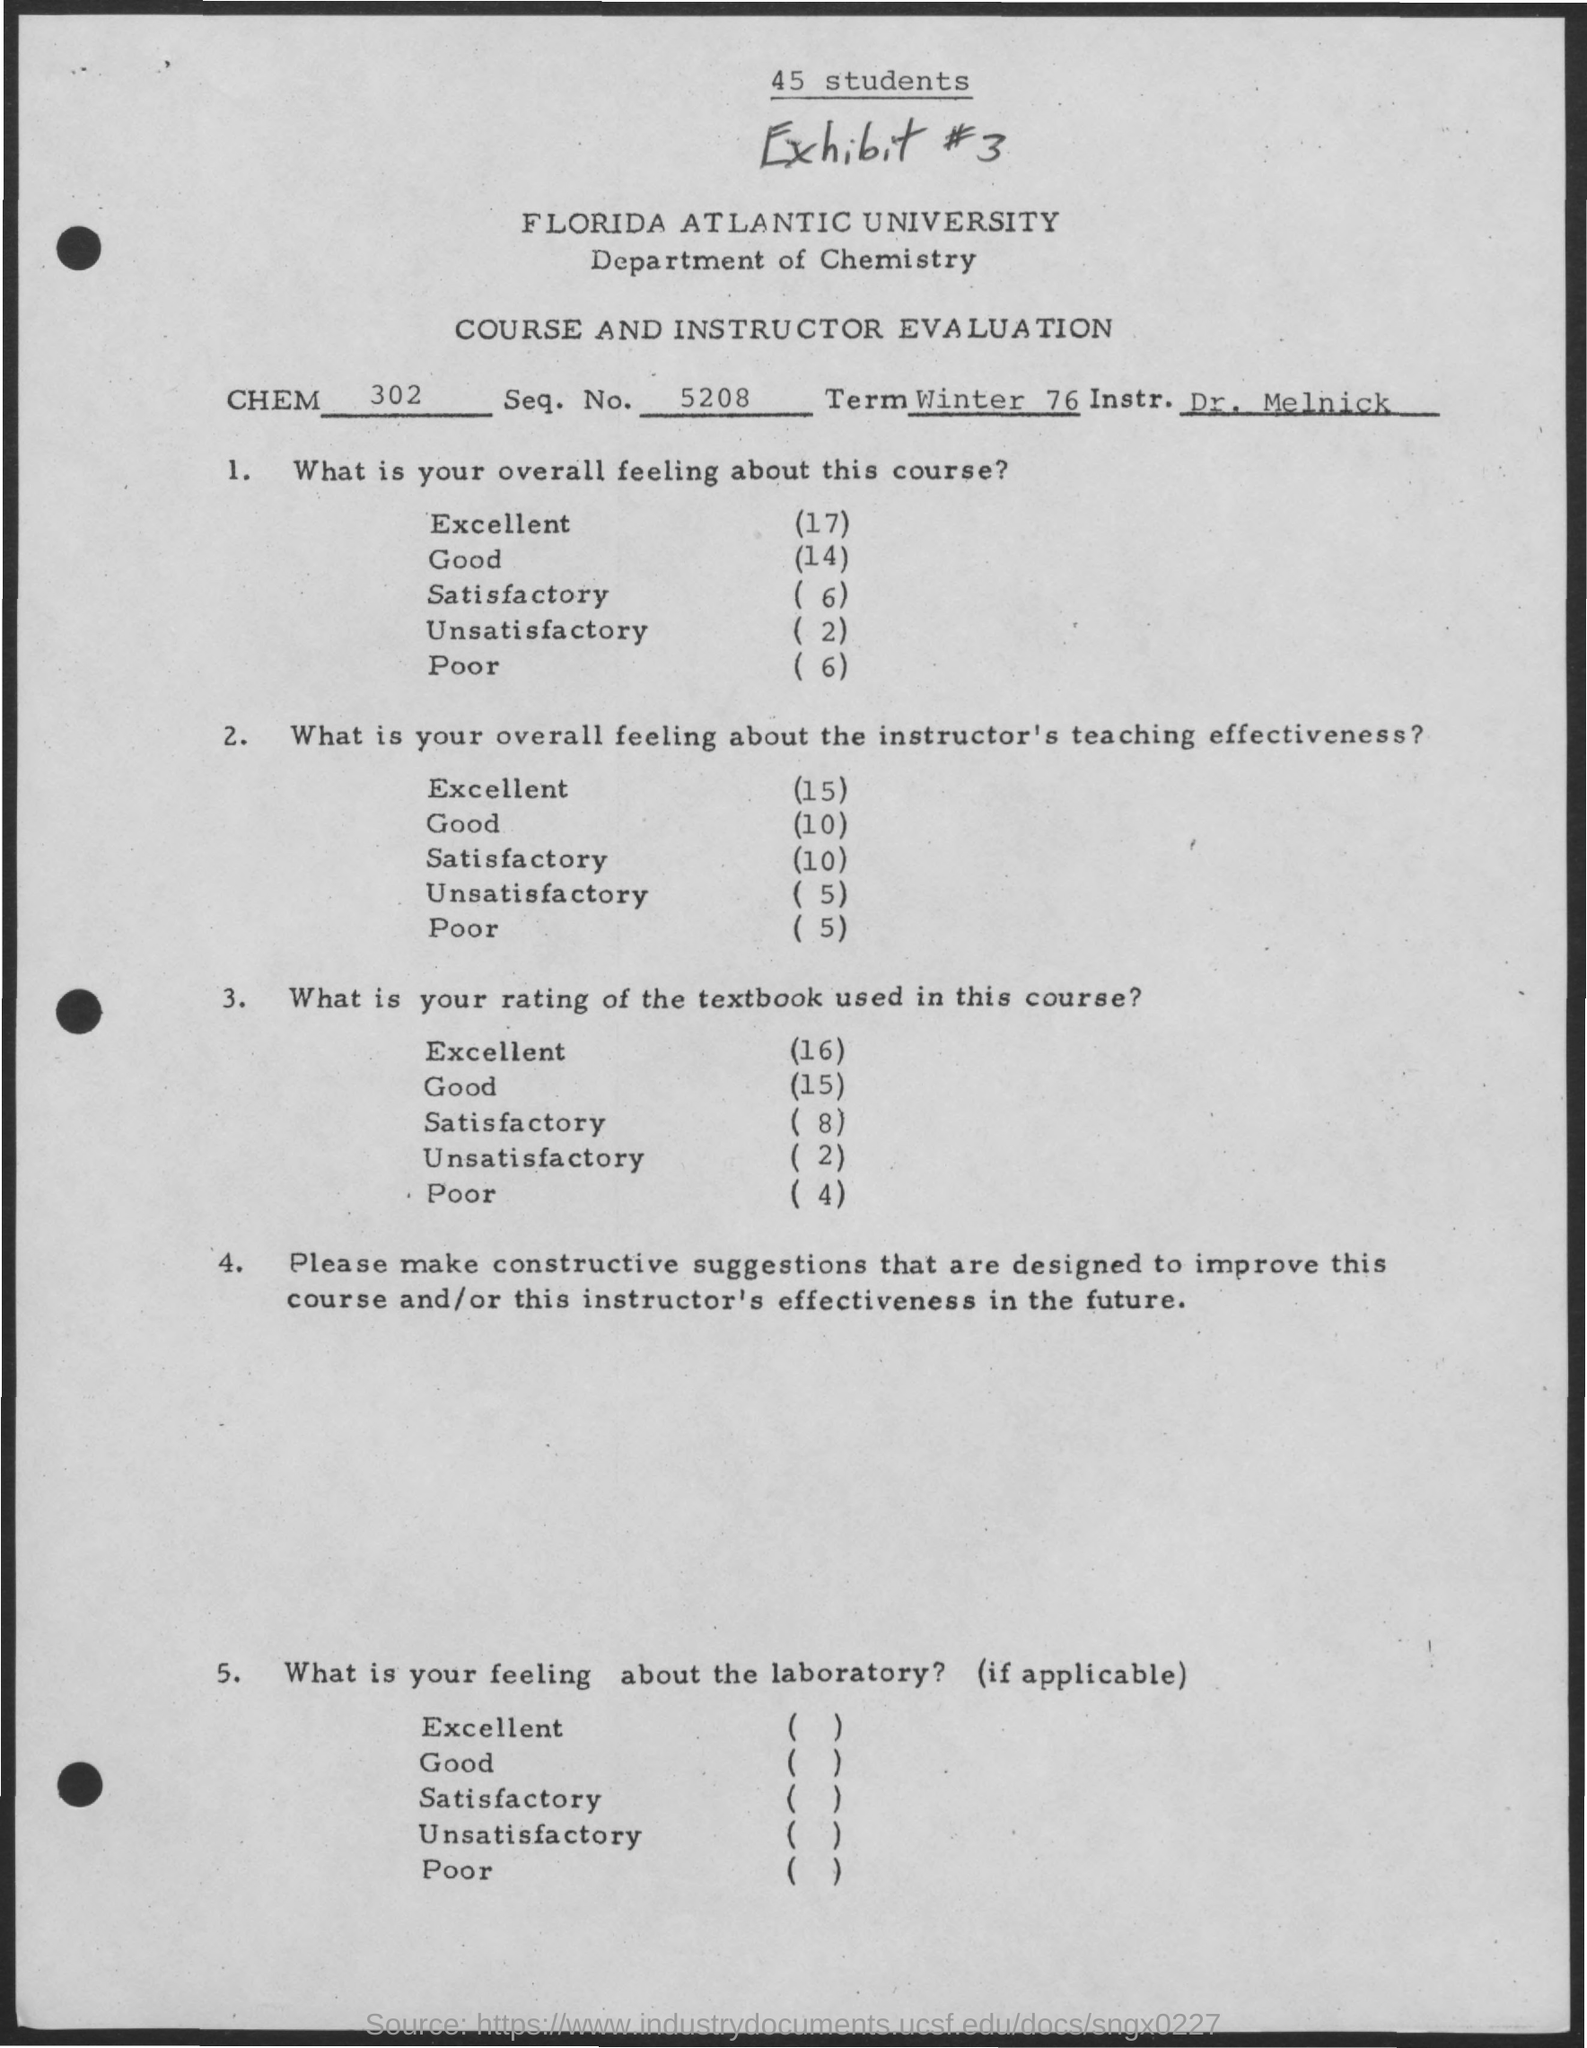Give some essential details in this illustration. The exhibit number is #3. What is the sequence number? 5208..." is a request for information about a sequence number. There are 45 students. The Department of Chemistry is the department that focuses on studying the properties and behavior of chemical compounds and substances. The chemical analysis report indicates that the value written in the CHEM field is 302. 